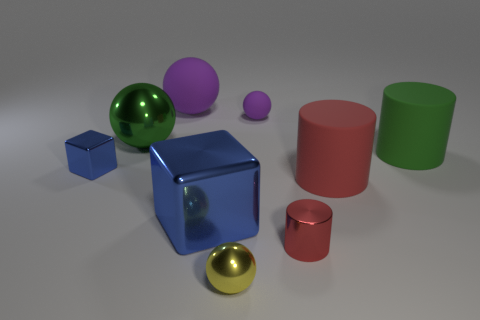Are there any rubber things of the same color as the tiny rubber sphere?
Your response must be concise. Yes. The other cylinder that is the same color as the metal cylinder is what size?
Give a very brief answer. Large. What number of tiny things are the same shape as the big purple thing?
Provide a succinct answer. 2. Is the number of small things that are in front of the green shiny ball greater than the number of tiny brown balls?
Give a very brief answer. Yes. What is the shape of the tiny object that is in front of the green ball and behind the red metallic thing?
Offer a very short reply. Cube. Do the yellow shiny object and the green cylinder have the same size?
Give a very brief answer. No. What number of big things are to the right of the large red rubber cylinder?
Provide a succinct answer. 1. Are there the same number of big purple spheres in front of the green rubber cylinder and metallic objects behind the tiny red shiny cylinder?
Ensure brevity in your answer.  No. Do the big rubber object that is to the left of the small yellow shiny ball and the tiny yellow thing have the same shape?
Your answer should be compact. Yes. There is a green sphere; does it have the same size as the green object that is on the right side of the tiny red object?
Keep it short and to the point. Yes. 